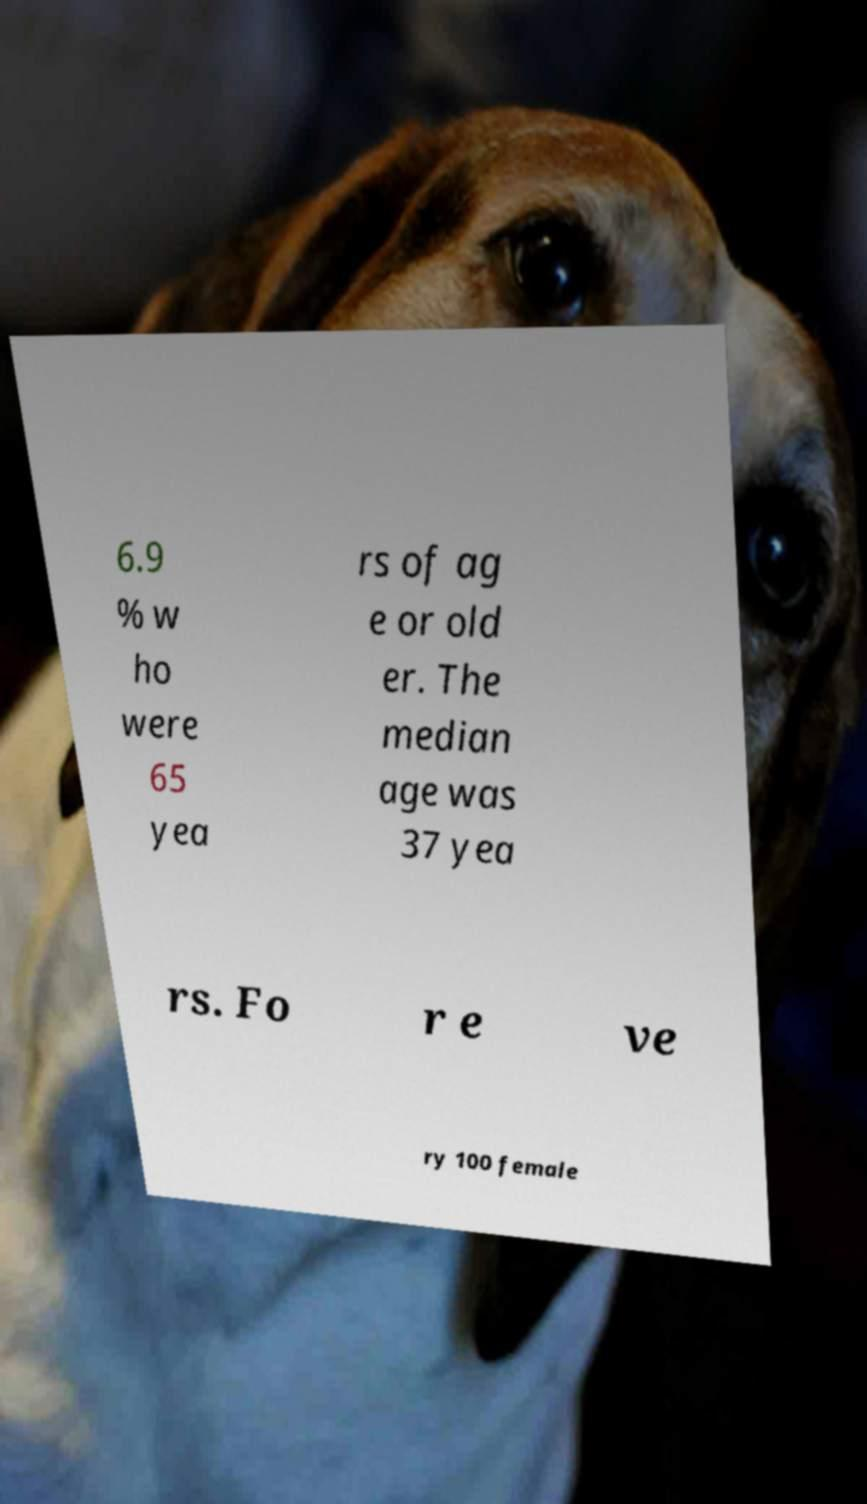I need the written content from this picture converted into text. Can you do that? 6.9 % w ho were 65 yea rs of ag e or old er. The median age was 37 yea rs. Fo r e ve ry 100 female 